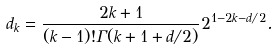Convert formula to latex. <formula><loc_0><loc_0><loc_500><loc_500>d _ { k } & = \frac { 2 k + 1 } { ( k - 1 ) ! \Gamma ( k + 1 + d / 2 ) } 2 ^ { 1 - 2 k - d / 2 } .</formula> 